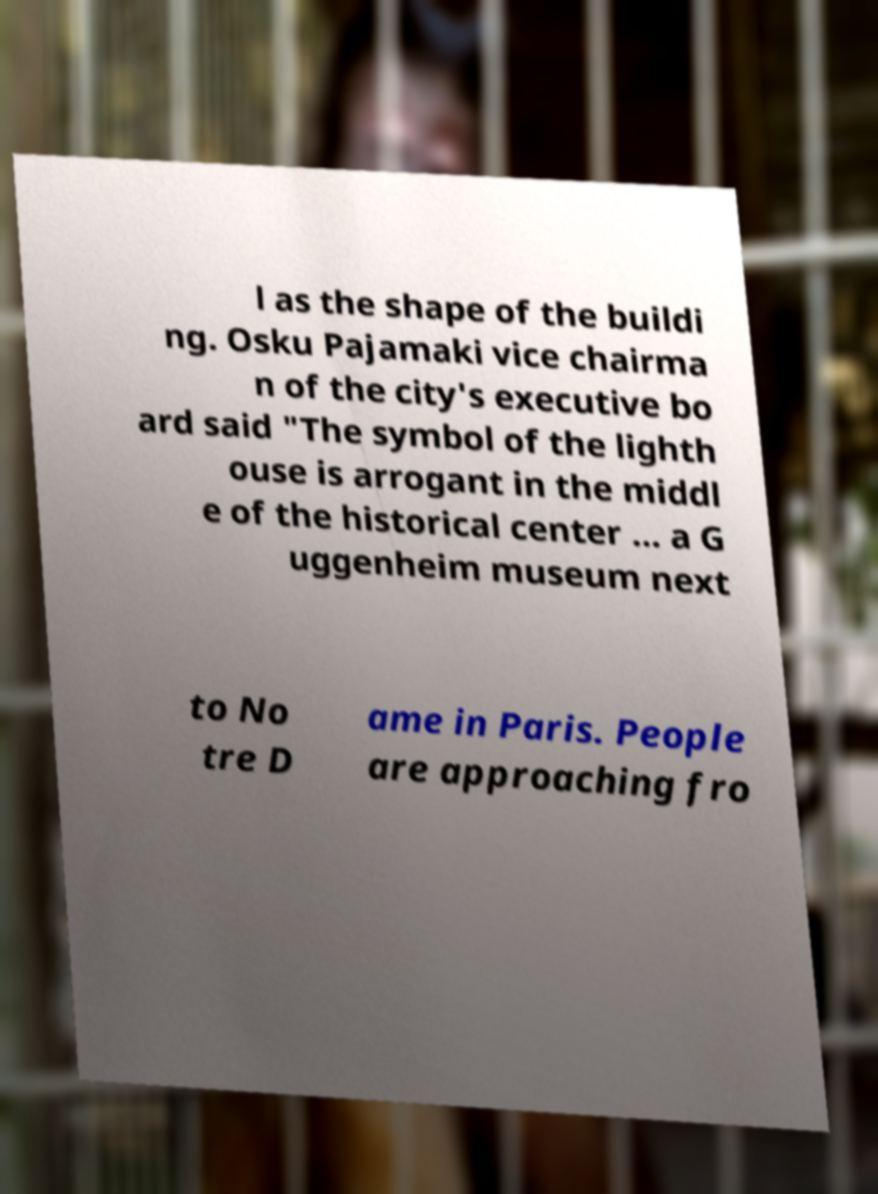What messages or text are displayed in this image? I need them in a readable, typed format. l as the shape of the buildi ng. Osku Pajamaki vice chairma n of the city's executive bo ard said "The symbol of the lighth ouse is arrogant in the middl e of the historical center ... a G uggenheim museum next to No tre D ame in Paris. People are approaching fro 